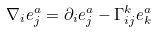<formula> <loc_0><loc_0><loc_500><loc_500>\nabla _ { i } e _ { j } ^ { a } = \partial _ { i } e _ { j } ^ { a } - \Gamma _ { i j } ^ { k } e _ { k } ^ { a }</formula> 